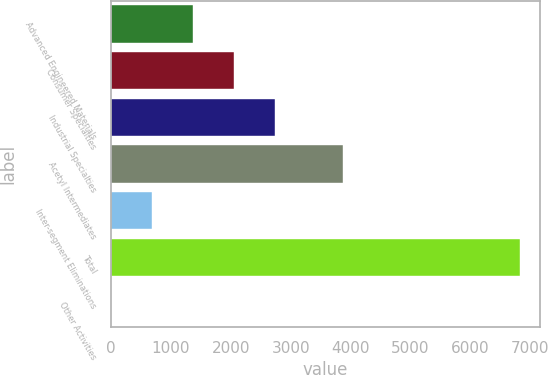<chart> <loc_0><loc_0><loc_500><loc_500><bar_chart><fcel>Advanced Engineered Materials<fcel>Consumer Specialties<fcel>Industrial Specialties<fcel>Acetyl Intermediates<fcel>Inter-segment Eliminations<fcel>Total<fcel>Other Activities<nl><fcel>1367.8<fcel>2049.7<fcel>2731.6<fcel>3875<fcel>685.9<fcel>6823<fcel>4<nl></chart> 